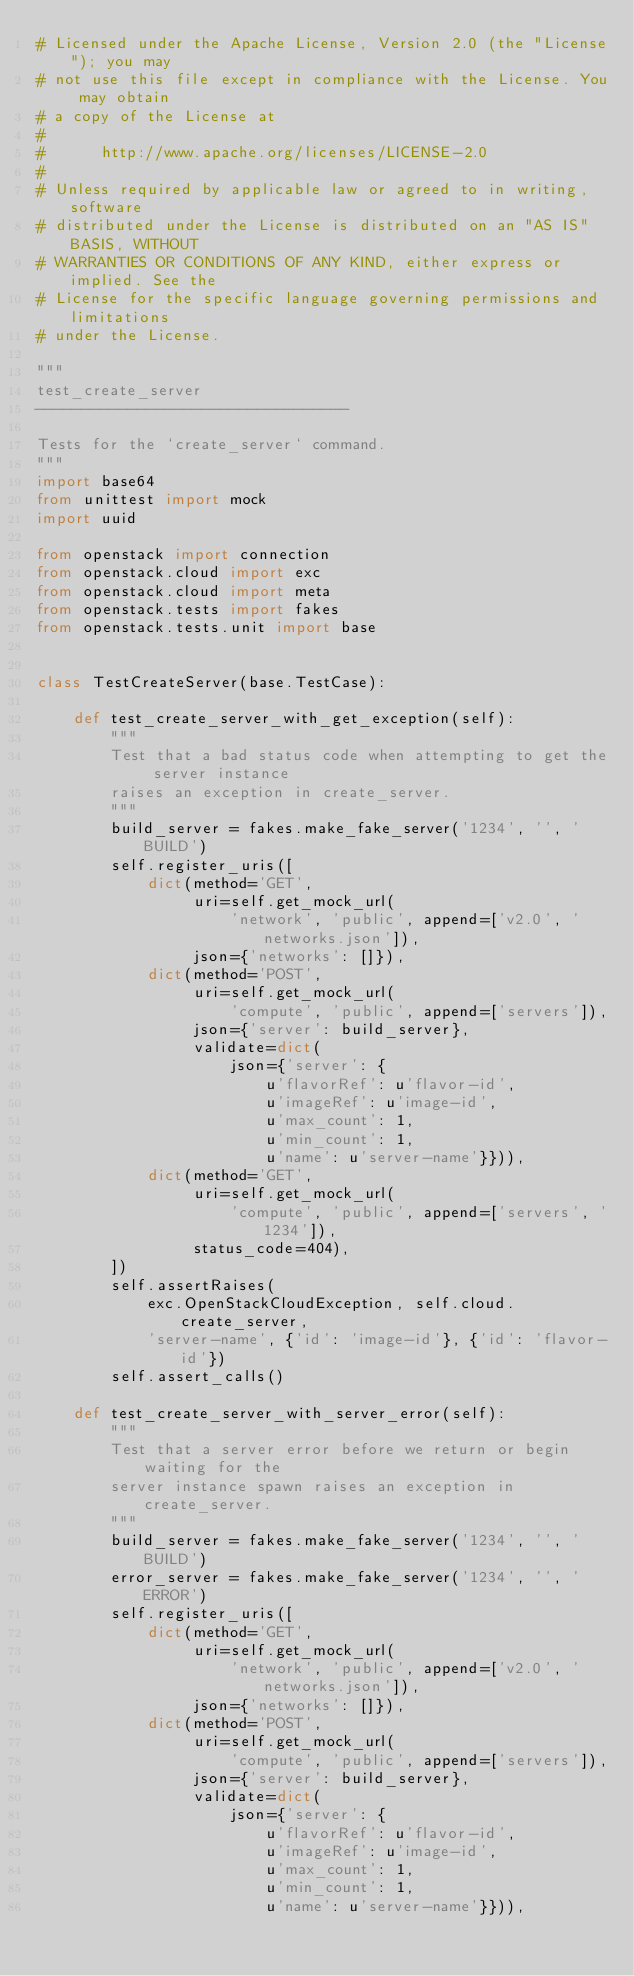Convert code to text. <code><loc_0><loc_0><loc_500><loc_500><_Python_># Licensed under the Apache License, Version 2.0 (the "License"); you may
# not use this file except in compliance with the License. You may obtain
# a copy of the License at
#
#      http://www.apache.org/licenses/LICENSE-2.0
#
# Unless required by applicable law or agreed to in writing, software
# distributed under the License is distributed on an "AS IS" BASIS, WITHOUT
# WARRANTIES OR CONDITIONS OF ANY KIND, either express or implied. See the
# License for the specific language governing permissions and limitations
# under the License.

"""
test_create_server
----------------------------------

Tests for the `create_server` command.
"""
import base64
from unittest import mock
import uuid

from openstack import connection
from openstack.cloud import exc
from openstack.cloud import meta
from openstack.tests import fakes
from openstack.tests.unit import base


class TestCreateServer(base.TestCase):

    def test_create_server_with_get_exception(self):
        """
        Test that a bad status code when attempting to get the server instance
        raises an exception in create_server.
        """
        build_server = fakes.make_fake_server('1234', '', 'BUILD')
        self.register_uris([
            dict(method='GET',
                 uri=self.get_mock_url(
                     'network', 'public', append=['v2.0', 'networks.json']),
                 json={'networks': []}),
            dict(method='POST',
                 uri=self.get_mock_url(
                     'compute', 'public', append=['servers']),
                 json={'server': build_server},
                 validate=dict(
                     json={'server': {
                         u'flavorRef': u'flavor-id',
                         u'imageRef': u'image-id',
                         u'max_count': 1,
                         u'min_count': 1,
                         u'name': u'server-name'}})),
            dict(method='GET',
                 uri=self.get_mock_url(
                     'compute', 'public', append=['servers', '1234']),
                 status_code=404),
        ])
        self.assertRaises(
            exc.OpenStackCloudException, self.cloud.create_server,
            'server-name', {'id': 'image-id'}, {'id': 'flavor-id'})
        self.assert_calls()

    def test_create_server_with_server_error(self):
        """
        Test that a server error before we return or begin waiting for the
        server instance spawn raises an exception in create_server.
        """
        build_server = fakes.make_fake_server('1234', '', 'BUILD')
        error_server = fakes.make_fake_server('1234', '', 'ERROR')
        self.register_uris([
            dict(method='GET',
                 uri=self.get_mock_url(
                     'network', 'public', append=['v2.0', 'networks.json']),
                 json={'networks': []}),
            dict(method='POST',
                 uri=self.get_mock_url(
                     'compute', 'public', append=['servers']),
                 json={'server': build_server},
                 validate=dict(
                     json={'server': {
                         u'flavorRef': u'flavor-id',
                         u'imageRef': u'image-id',
                         u'max_count': 1,
                         u'min_count': 1,
                         u'name': u'server-name'}})),</code> 